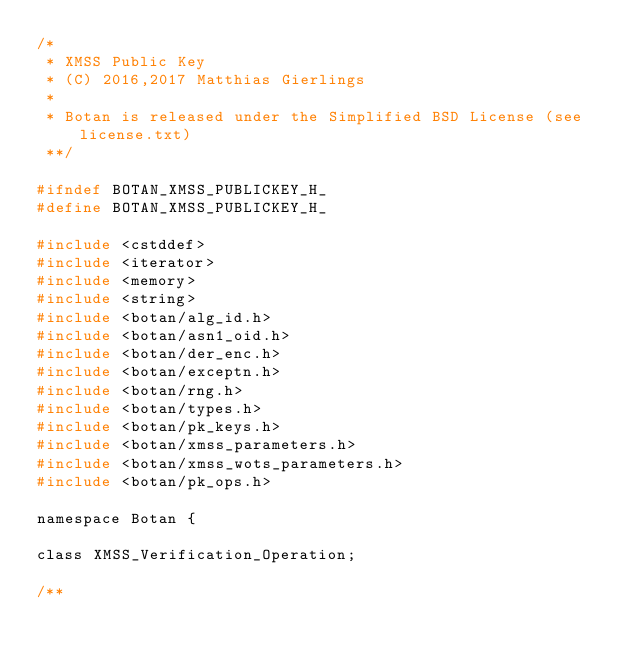Convert code to text. <code><loc_0><loc_0><loc_500><loc_500><_C_>/*
 * XMSS Public Key
 * (C) 2016,2017 Matthias Gierlings
 *
 * Botan is released under the Simplified BSD License (see license.txt)
 **/

#ifndef BOTAN_XMSS_PUBLICKEY_H_
#define BOTAN_XMSS_PUBLICKEY_H_

#include <cstddef>
#include <iterator>
#include <memory>
#include <string>
#include <botan/alg_id.h>
#include <botan/asn1_oid.h>
#include <botan/der_enc.h>
#include <botan/exceptn.h>
#include <botan/rng.h>
#include <botan/types.h>
#include <botan/pk_keys.h>
#include <botan/xmss_parameters.h>
#include <botan/xmss_wots_parameters.h>
#include <botan/pk_ops.h>

namespace Botan {

class XMSS_Verification_Operation;

/**</code> 